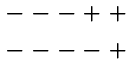<formula> <loc_0><loc_0><loc_500><loc_500>\begin{array} { c } - - - + + \\ - - - - + \end{array}</formula> 